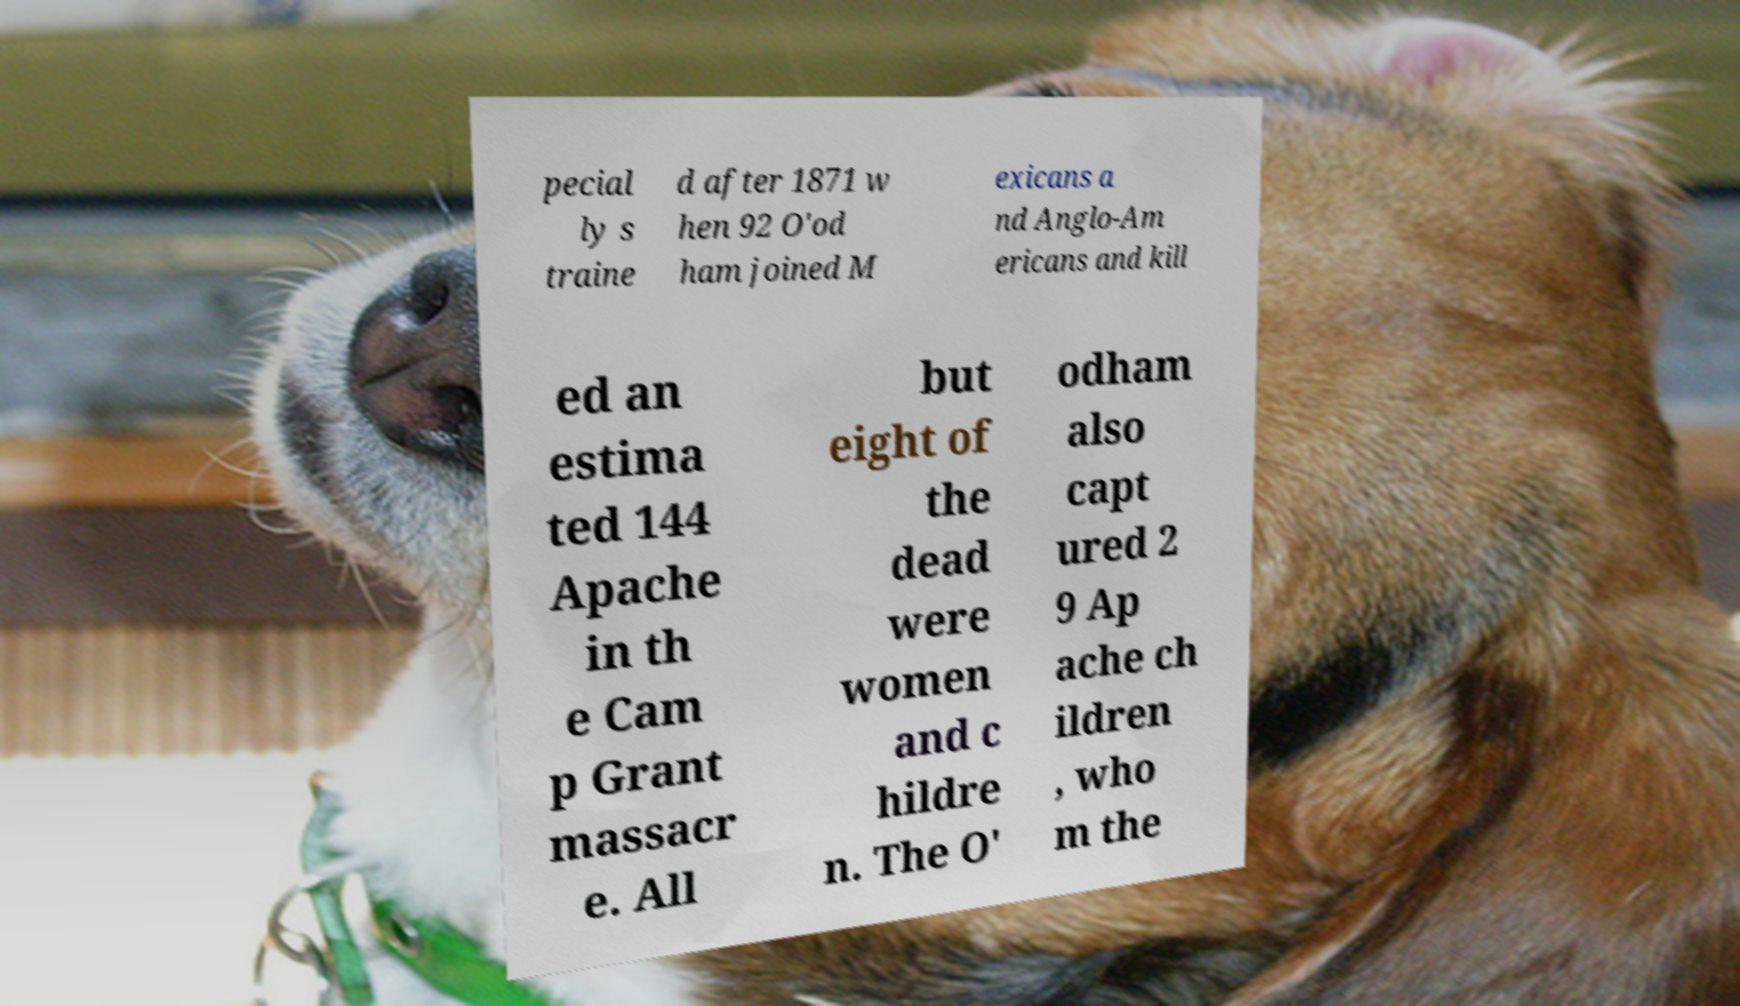Please identify and transcribe the text found in this image. pecial ly s traine d after 1871 w hen 92 O'od ham joined M exicans a nd Anglo-Am ericans and kill ed an estima ted 144 Apache in th e Cam p Grant massacr e. All but eight of the dead were women and c hildre n. The O' odham also capt ured 2 9 Ap ache ch ildren , who m the 